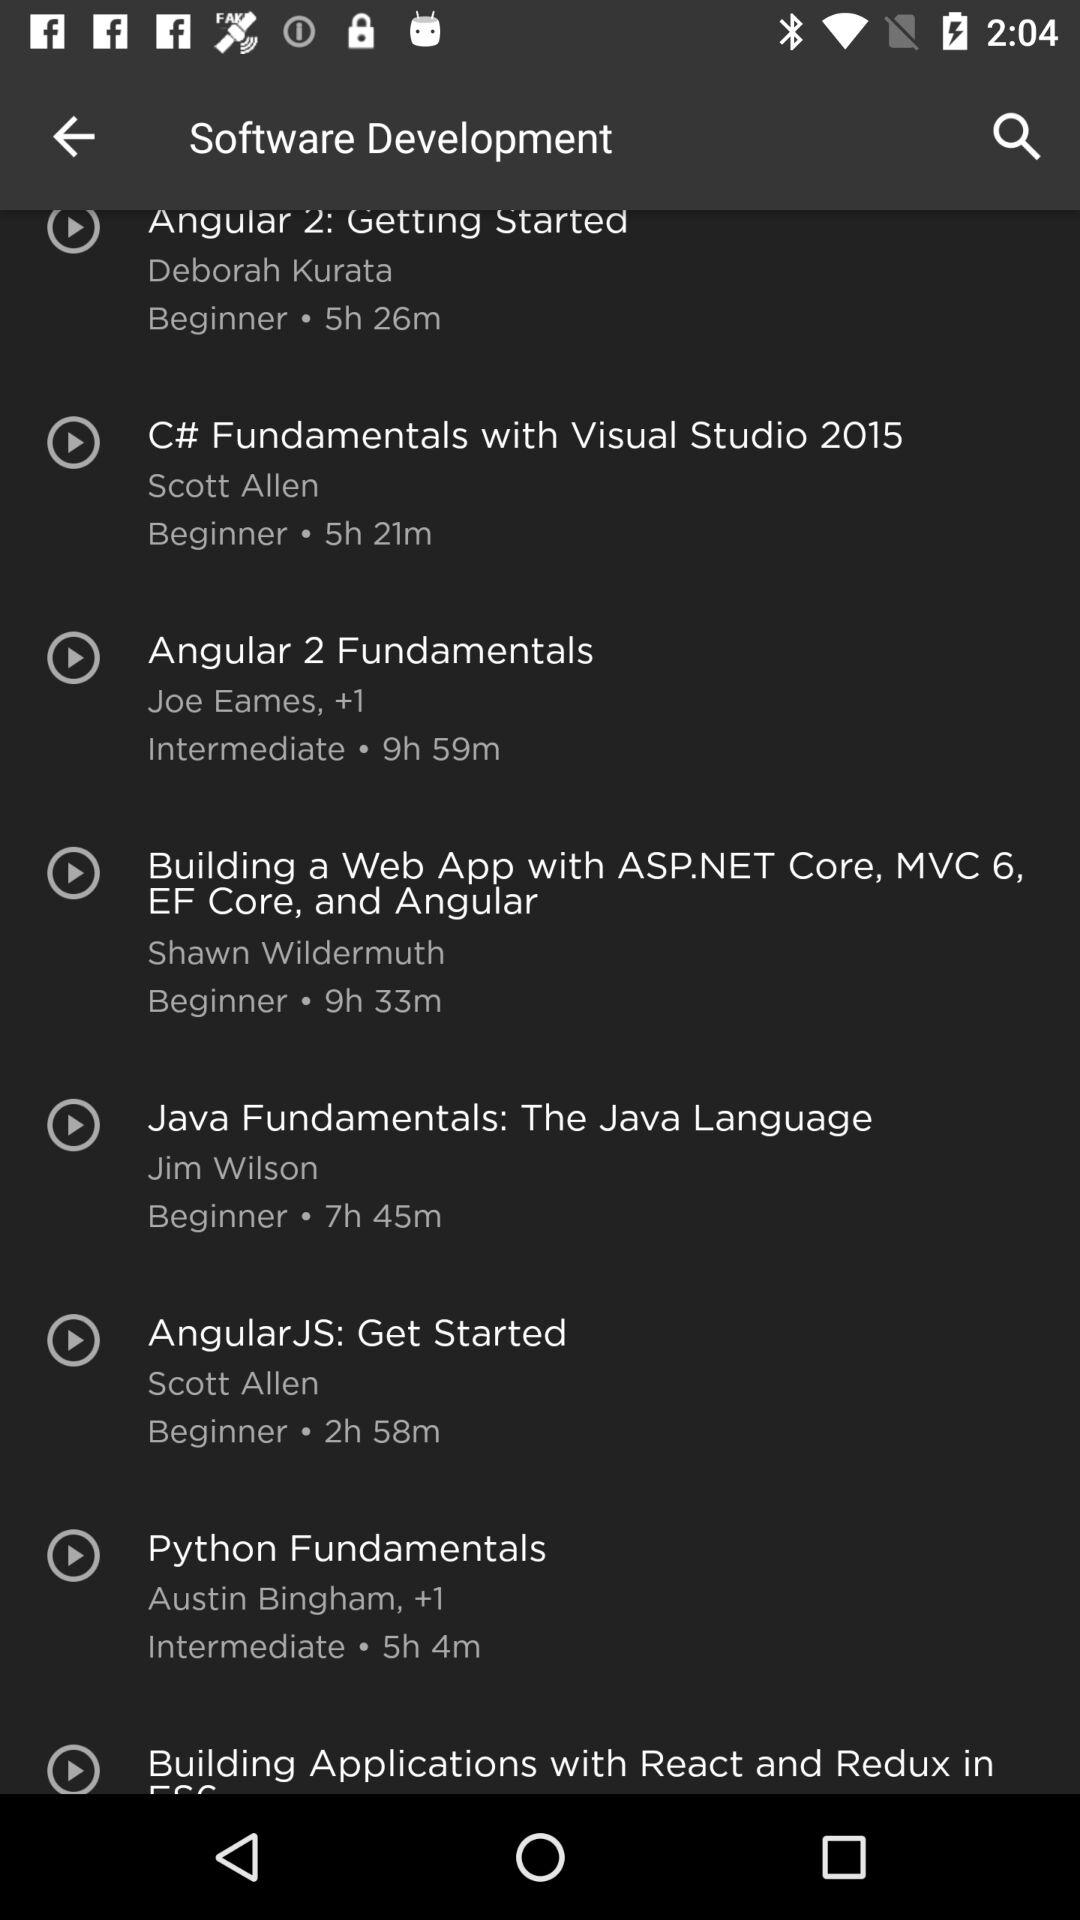What is the duration of the "Angular 2: Getting Started" course? The duration of the "Angular 2: Getting Started" course is 5 hours 26 minutes. 